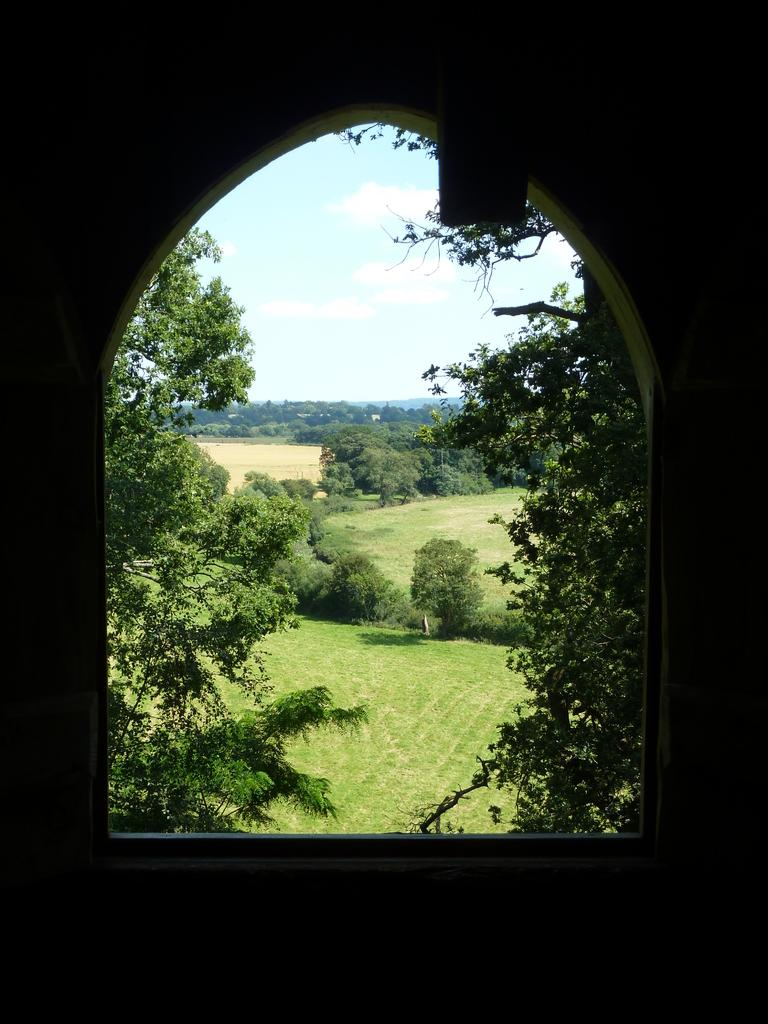What is located in the middle of the image? There are trees in the middle of the image. What is visible at the top of the image? The sky is visible at the top of the image. From where might the image have been taken? The image was likely taken from a building. What type of jeans are hanging on the trees in the image? There are no jeans present in the image; it features trees and the sky. What direction is the image facing? The direction the image is facing cannot be determined from the provided facts. 